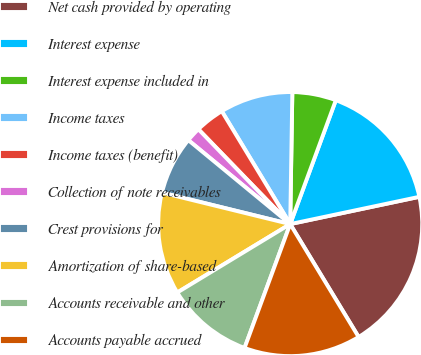Convert chart to OTSL. <chart><loc_0><loc_0><loc_500><loc_500><pie_chart><fcel>Net cash provided by operating<fcel>Interest expense<fcel>Interest expense included in<fcel>Income taxes<fcel>Income taxes (benefit)<fcel>Collection of note receivables<fcel>Crest provisions for<fcel>Amortization of share-based<fcel>Accounts receivable and other<fcel>Accounts payable accrued<nl><fcel>19.64%<fcel>16.07%<fcel>5.36%<fcel>8.93%<fcel>3.57%<fcel>1.79%<fcel>7.14%<fcel>12.5%<fcel>10.71%<fcel>14.29%<nl></chart> 